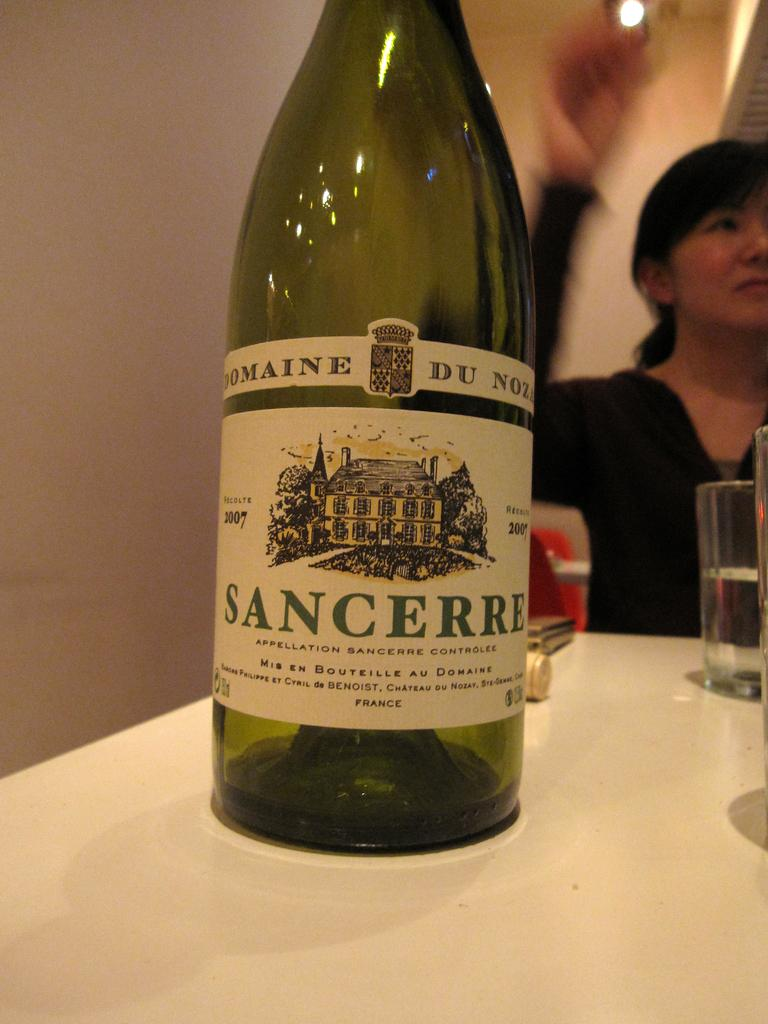What is on the table in the image? There is a wine bottle and a glass on the table. What is the woman in the image doing? The woman is sitting in the image. What can be seen in the background of the image? There is a wall visible in the background. What type of humor is the woman displaying in the image? There is no indication of humor in the image; the woman is simply sitting. What force is being applied to the wine bottle in the image? There is no force being applied to the wine bottle in the image; it is stationary on the table. 